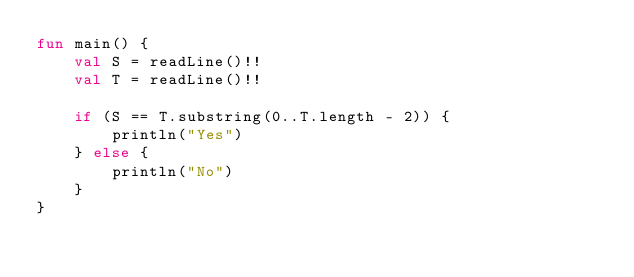<code> <loc_0><loc_0><loc_500><loc_500><_Kotlin_>fun main() {
    val S = readLine()!!
    val T = readLine()!!

    if (S == T.substring(0..T.length - 2)) {
        println("Yes")
    } else {
        println("No")
    }
}</code> 